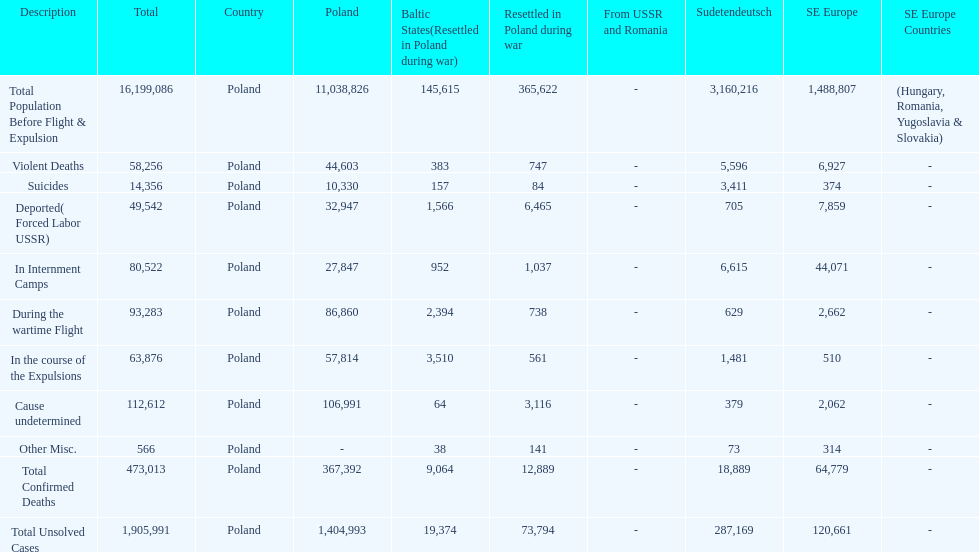Help me parse the entirety of this table. {'header': ['Description', 'Total', 'Country', 'Poland', 'Baltic States(Resettled in Poland during war)', 'Resettled in Poland during war', 'From USSR and Romania', 'Sudetendeutsch', 'SE Europe', 'SE Europe Countries'], 'rows': [['Total Population Before Flight & Expulsion', '16,199,086', 'Poland', '11,038,826', '145,615', '365,622', '-', '3,160,216', '1,488,807', '(Hungary, Romania, Yugoslavia & Slovakia)'], ['Violent Deaths', '58,256', 'Poland', '44,603', '383', '747', '-', '5,596', '6,927', '-'], ['Suicides', '14,356', 'Poland', '10,330', '157', '84', '-', '3,411', '374', '-'], ['Deported( Forced Labor USSR)', '49,542', 'Poland', '32,947', '1,566', '6,465', '-', '705', '7,859', '-'], ['In Internment Camps', '80,522', 'Poland', '27,847', '952', '1,037', '-', '6,615', '44,071', '-'], ['During the wartime Flight', '93,283', 'Poland', '86,860', '2,394', '738', '-', '629', '2,662', '-'], ['In the course of the Expulsions', '63,876', 'Poland', '57,814', '3,510', '561', '-', '1,481', '510', '-'], ['Cause undetermined', '112,612', 'Poland', '106,991', '64', '3,116', '-', '379', '2,062', '-'], ['Other Misc.', '566', 'Poland', '-', '38', '141', '-', '73', '314', '-'], ['Total Confirmed Deaths', '473,013', 'Poland', '367,392', '9,064', '12,889', '-', '18,889', '64,779', '-'], ['Total Unsolved Cases', '1,905,991', 'Poland', '1,404,993', '19,374', '73,794', '-', '287,169', '120,661', '-']]} Did any location have no violent deaths? No. 